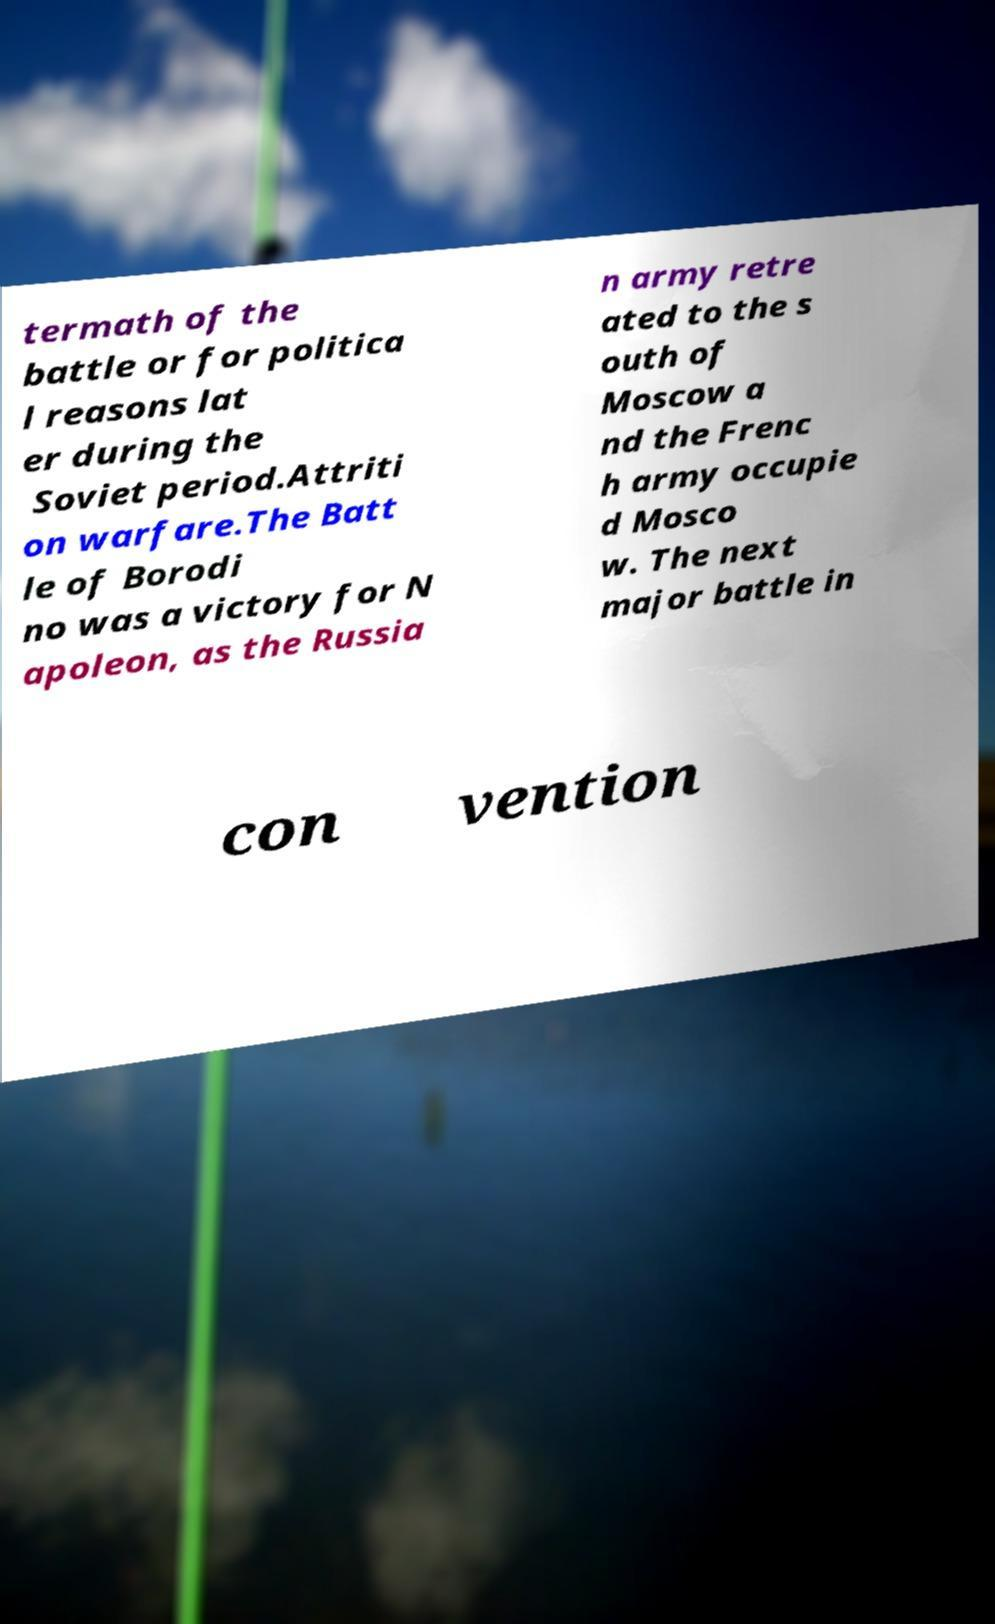What messages or text are displayed in this image? I need them in a readable, typed format. termath of the battle or for politica l reasons lat er during the Soviet period.Attriti on warfare.The Batt le of Borodi no was a victory for N apoleon, as the Russia n army retre ated to the s outh of Moscow a nd the Frenc h army occupie d Mosco w. The next major battle in con vention 